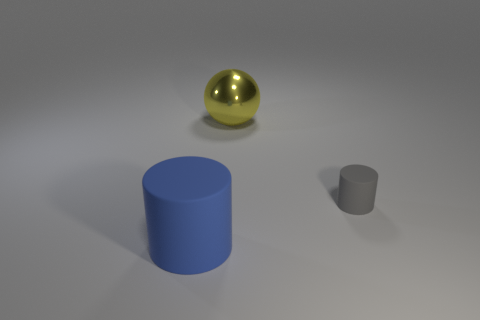Add 3 big spheres. How many objects exist? 6 Subtract all blue cylinders. How many cylinders are left? 1 Subtract all balls. How many objects are left? 2 Subtract 2 cylinders. How many cylinders are left? 0 Subtract all cyan cylinders. Subtract all cyan balls. How many cylinders are left? 2 Subtract all big shiny objects. Subtract all large blue things. How many objects are left? 1 Add 1 tiny matte things. How many tiny matte things are left? 2 Add 1 big green metal things. How many big green metal things exist? 1 Subtract 0 gray cubes. How many objects are left? 3 